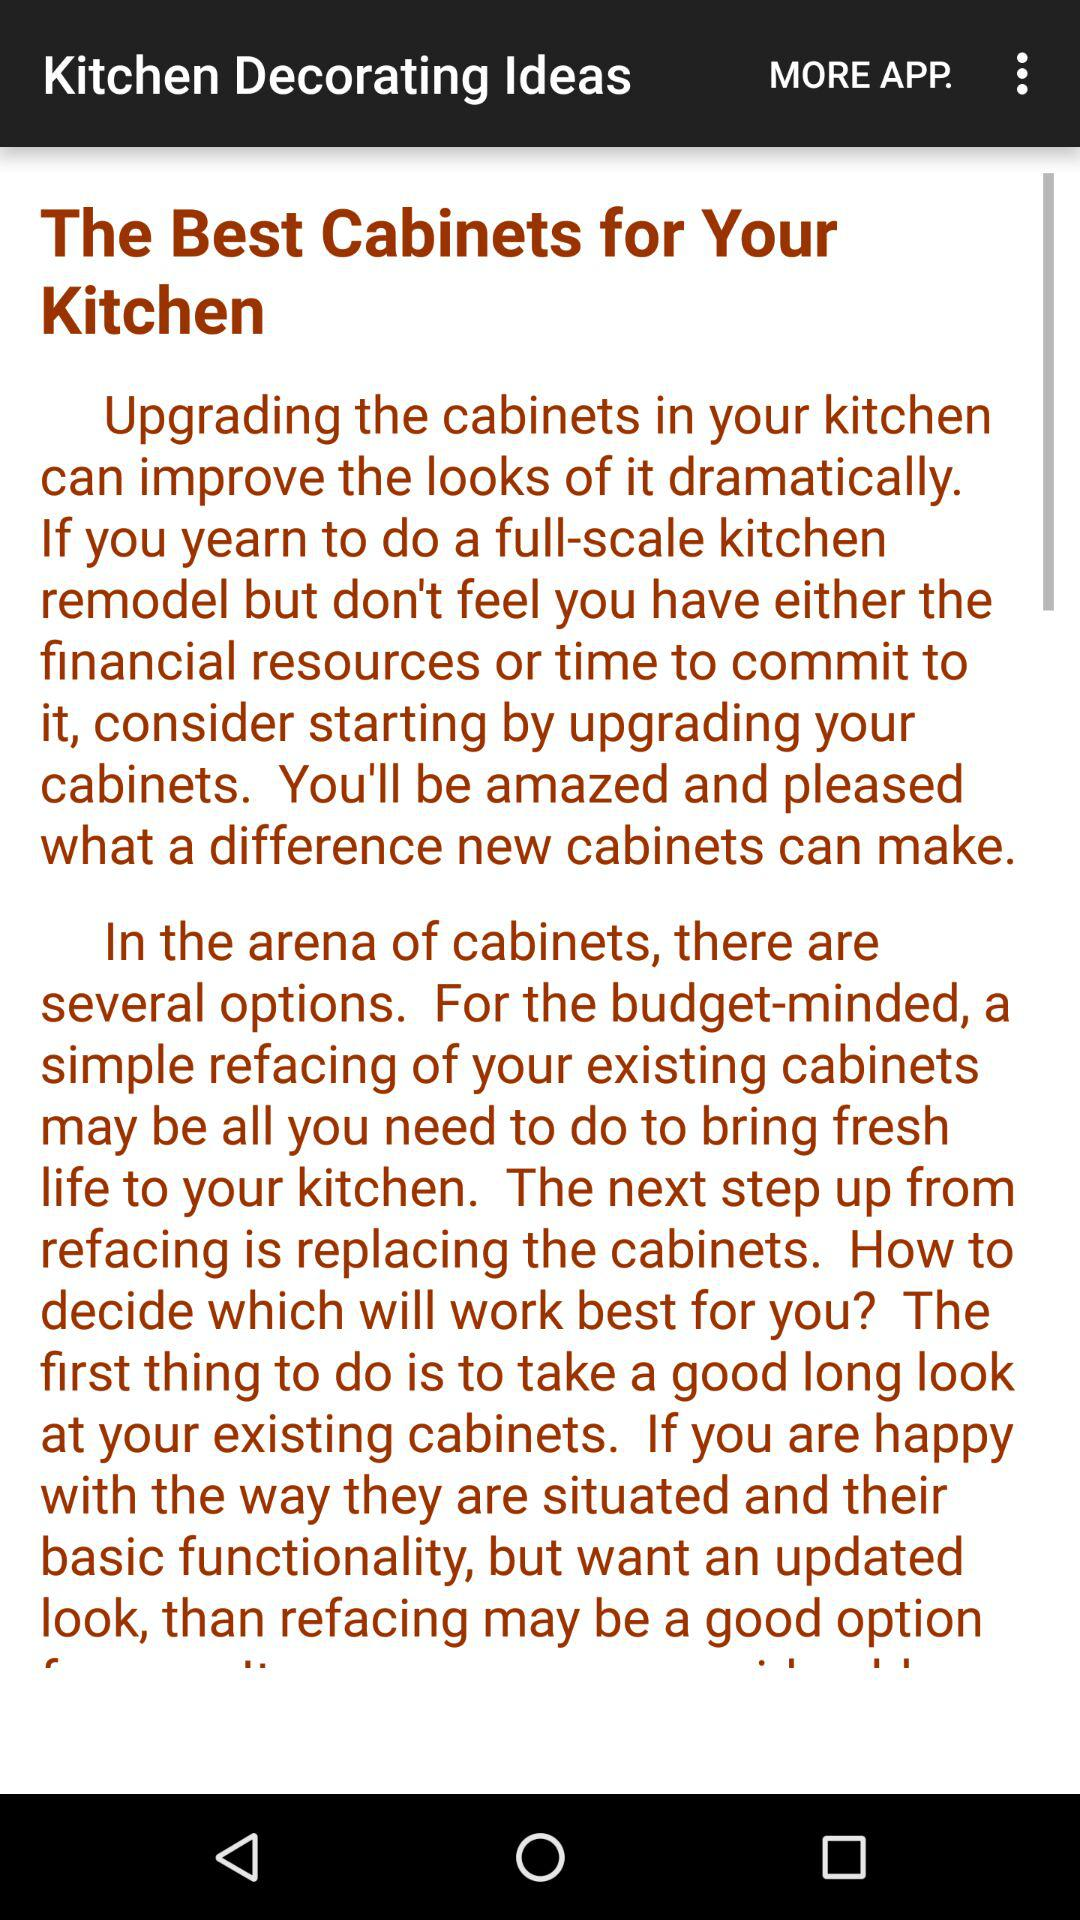What is the name of the application? The name of the application is "Kitchen Decorating Ideas". 